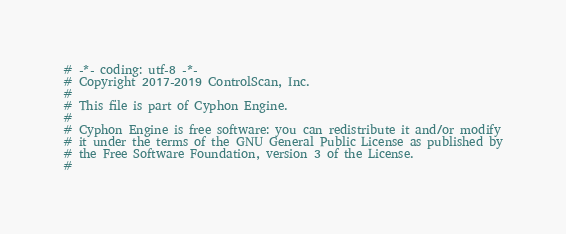<code> <loc_0><loc_0><loc_500><loc_500><_Python_># -*- coding: utf-8 -*-
# Copyright 2017-2019 ControlScan, Inc.
#
# This file is part of Cyphon Engine.
#
# Cyphon Engine is free software: you can redistribute it and/or modify
# it under the terms of the GNU General Public License as published by
# the Free Software Foundation, version 3 of the License.
#</code> 